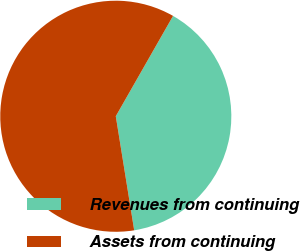<chart> <loc_0><loc_0><loc_500><loc_500><pie_chart><fcel>Revenues from continuing<fcel>Assets from continuing<nl><fcel>39.2%<fcel>60.8%<nl></chart> 